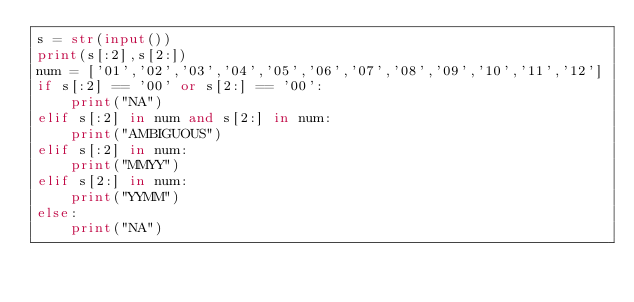<code> <loc_0><loc_0><loc_500><loc_500><_Python_>s = str(input())
print(s[:2],s[2:])
num = ['01','02','03','04','05','06','07','08','09','10','11','12']
if s[:2] == '00' or s[2:] == '00':
    print("NA")
elif s[:2] in num and s[2:] in num:
    print("AMBIGUOUS")
elif s[:2] in num:
    print("MMYY")
elif s[2:] in num:
    print("YYMM")
else:
    print("NA")</code> 